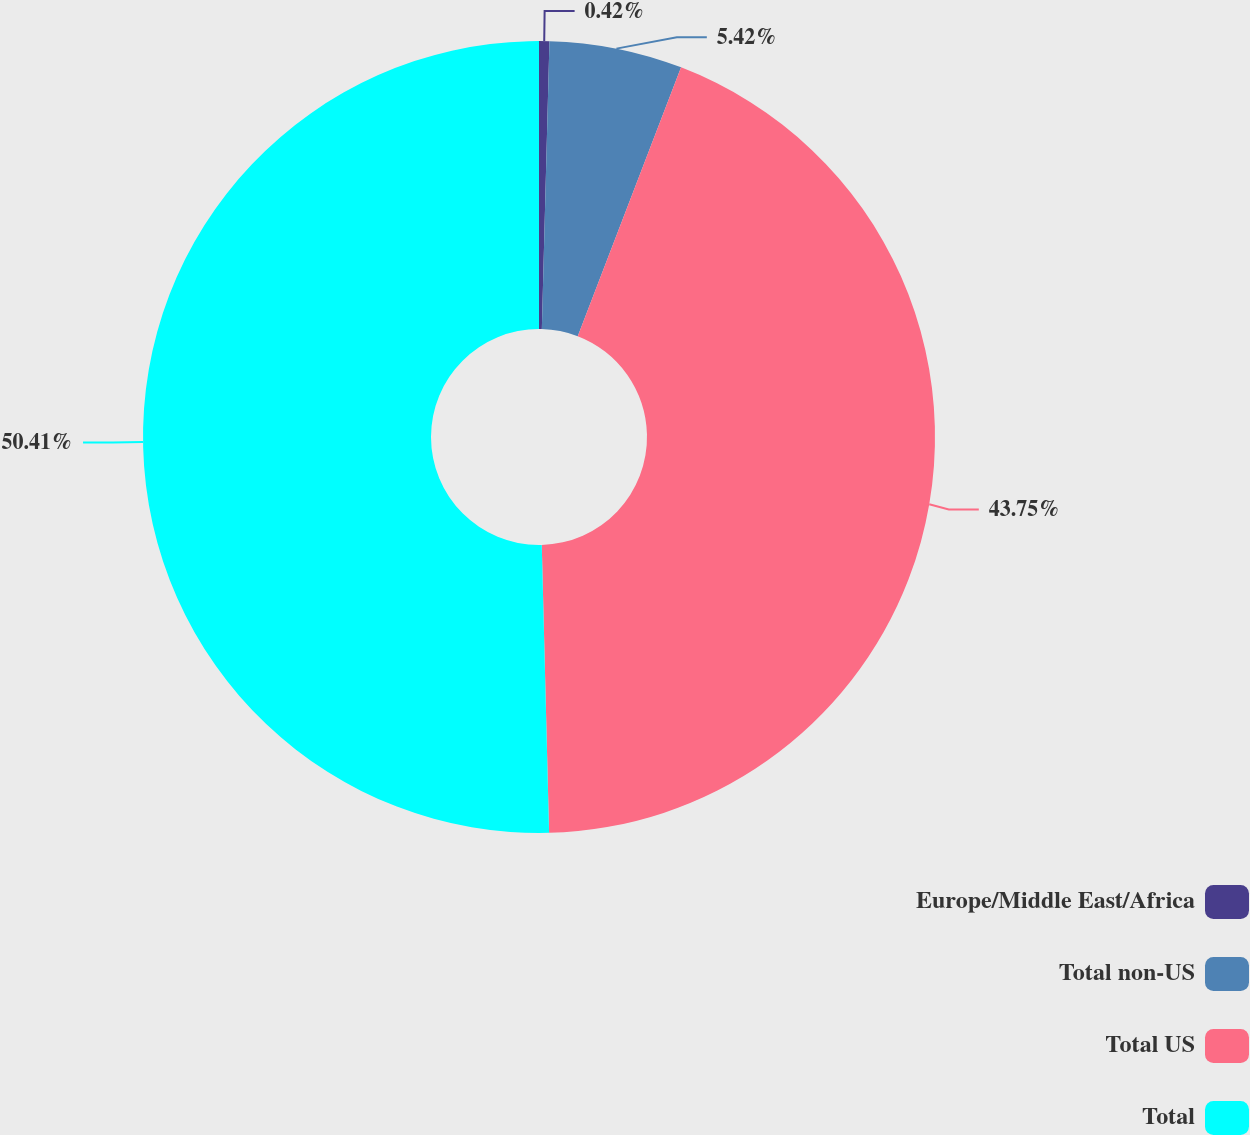Convert chart. <chart><loc_0><loc_0><loc_500><loc_500><pie_chart><fcel>Europe/Middle East/Africa<fcel>Total non-US<fcel>Total US<fcel>Total<nl><fcel>0.42%<fcel>5.42%<fcel>43.75%<fcel>50.4%<nl></chart> 